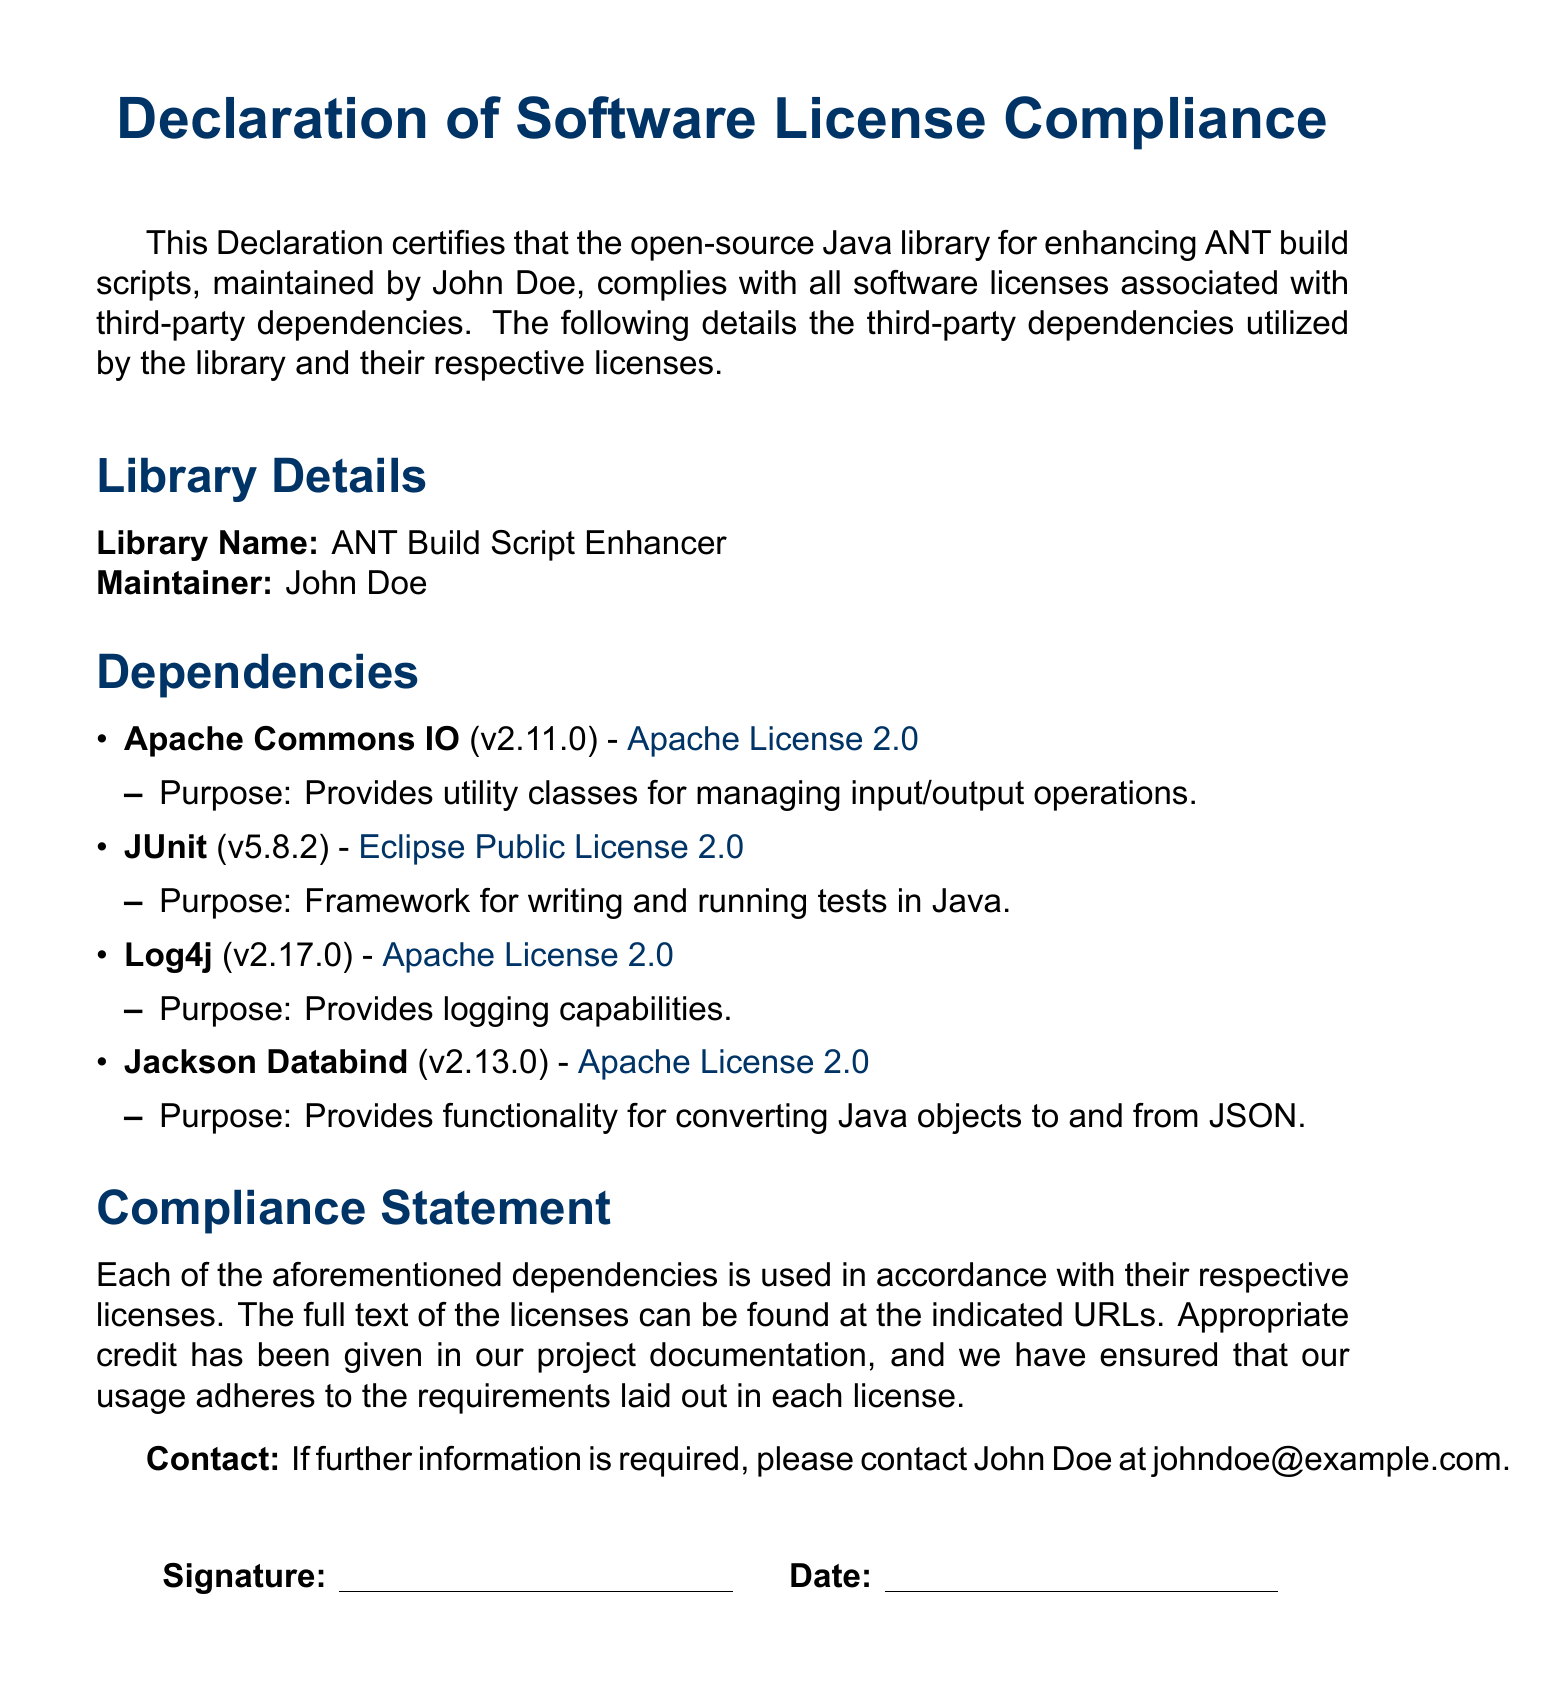What is the library name? The library name is stated clearly in the document.
Answer: ANT Build Script Enhancer Who is the maintainer? The maintainer's name is provided in the declaration section.
Answer: John Doe What is the version of JUnit? The specific version of JUnit can be found in the dependencies section.
Answer: v5.8.2 What license does Apache Commons IO use? The license type is mentioned next to the dependency in the document.
Answer: Apache License 2.0 What is the purpose of Jackson Databind? The purpose for Jackson Databind is elaborated in the dependencies list.
Answer: Provides functionality for converting Java objects to and from JSON How many dependencies are listed? The number of dependencies can be counted in the dependencies section.
Answer: Four Where can the full text of the licenses be found? The document references the location of the licenses.
Answer: Indicated URLs What is the contact email for further information? The document provides a contact email for inquiries.
Answer: johndoe@example.com 